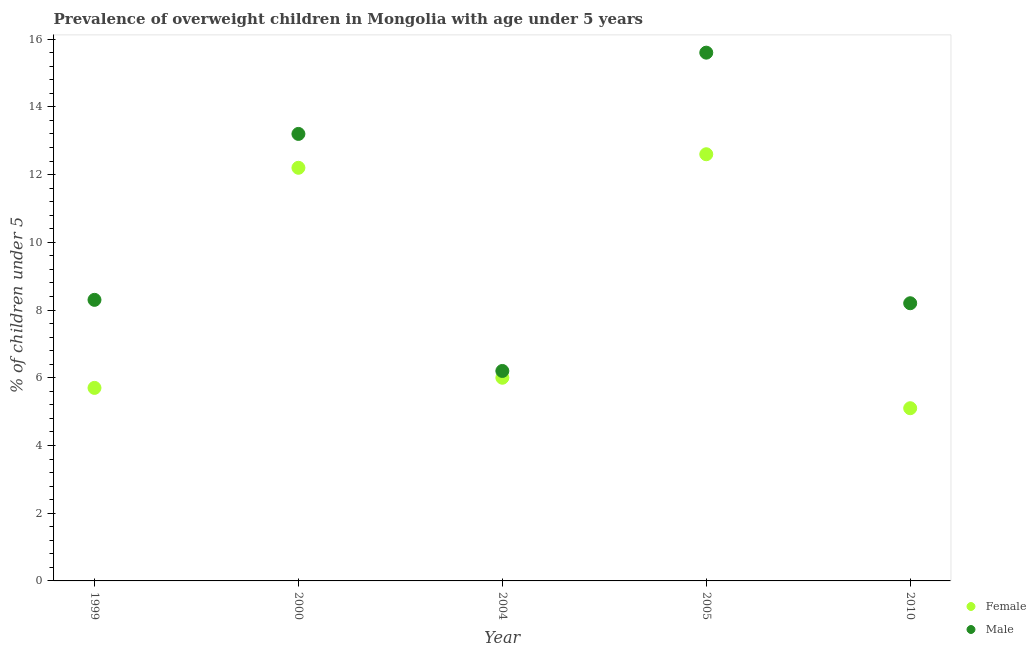Is the number of dotlines equal to the number of legend labels?
Offer a very short reply. Yes. What is the percentage of obese female children in 2000?
Provide a short and direct response. 12.2. Across all years, what is the maximum percentage of obese female children?
Your answer should be very brief. 12.6. Across all years, what is the minimum percentage of obese male children?
Offer a very short reply. 6.2. In which year was the percentage of obese female children maximum?
Make the answer very short. 2005. What is the total percentage of obese female children in the graph?
Give a very brief answer. 41.6. What is the difference between the percentage of obese female children in 2000 and that in 2005?
Make the answer very short. -0.4. What is the difference between the percentage of obese male children in 1999 and the percentage of obese female children in 2004?
Your answer should be compact. 2.3. What is the average percentage of obese male children per year?
Keep it short and to the point. 10.3. In how many years, is the percentage of obese female children greater than 2.8 %?
Keep it short and to the point. 5. What is the ratio of the percentage of obese female children in 2004 to that in 2005?
Offer a terse response. 0.48. What is the difference between the highest and the second highest percentage of obese female children?
Your answer should be very brief. 0.4. What is the difference between the highest and the lowest percentage of obese female children?
Offer a very short reply. 7.5. Is the sum of the percentage of obese male children in 1999 and 2010 greater than the maximum percentage of obese female children across all years?
Keep it short and to the point. Yes. How many years are there in the graph?
Make the answer very short. 5. What is the difference between two consecutive major ticks on the Y-axis?
Provide a succinct answer. 2. Are the values on the major ticks of Y-axis written in scientific E-notation?
Ensure brevity in your answer.  No. Where does the legend appear in the graph?
Make the answer very short. Bottom right. How many legend labels are there?
Your answer should be compact. 2. What is the title of the graph?
Keep it short and to the point. Prevalence of overweight children in Mongolia with age under 5 years. What is the label or title of the X-axis?
Make the answer very short. Year. What is the label or title of the Y-axis?
Your answer should be compact.  % of children under 5. What is the  % of children under 5 of Female in 1999?
Make the answer very short. 5.7. What is the  % of children under 5 of Male in 1999?
Make the answer very short. 8.3. What is the  % of children under 5 of Female in 2000?
Keep it short and to the point. 12.2. What is the  % of children under 5 of Male in 2000?
Ensure brevity in your answer.  13.2. What is the  % of children under 5 in Female in 2004?
Keep it short and to the point. 6. What is the  % of children under 5 of Male in 2004?
Offer a terse response. 6.2. What is the  % of children under 5 in Female in 2005?
Provide a succinct answer. 12.6. What is the  % of children under 5 in Male in 2005?
Keep it short and to the point. 15.6. What is the  % of children under 5 of Female in 2010?
Give a very brief answer. 5.1. What is the  % of children under 5 in Male in 2010?
Keep it short and to the point. 8.2. Across all years, what is the maximum  % of children under 5 in Female?
Provide a short and direct response. 12.6. Across all years, what is the maximum  % of children under 5 of Male?
Make the answer very short. 15.6. Across all years, what is the minimum  % of children under 5 in Female?
Keep it short and to the point. 5.1. Across all years, what is the minimum  % of children under 5 of Male?
Give a very brief answer. 6.2. What is the total  % of children under 5 of Female in the graph?
Ensure brevity in your answer.  41.6. What is the total  % of children under 5 of Male in the graph?
Your answer should be very brief. 51.5. What is the difference between the  % of children under 5 of Female in 1999 and that in 2000?
Your answer should be very brief. -6.5. What is the difference between the  % of children under 5 of Male in 1999 and that in 2000?
Provide a short and direct response. -4.9. What is the difference between the  % of children under 5 of Female in 1999 and that in 2004?
Provide a succinct answer. -0.3. What is the difference between the  % of children under 5 in Female in 1999 and that in 2005?
Your response must be concise. -6.9. What is the difference between the  % of children under 5 in Female in 1999 and that in 2010?
Make the answer very short. 0.6. What is the difference between the  % of children under 5 in Male in 1999 and that in 2010?
Your answer should be compact. 0.1. What is the difference between the  % of children under 5 in Female in 2000 and that in 2005?
Your answer should be very brief. -0.4. What is the difference between the  % of children under 5 in Male in 2000 and that in 2005?
Ensure brevity in your answer.  -2.4. What is the difference between the  % of children under 5 of Male in 2000 and that in 2010?
Ensure brevity in your answer.  5. What is the difference between the  % of children under 5 in Female in 2004 and that in 2010?
Ensure brevity in your answer.  0.9. What is the difference between the  % of children under 5 of Male in 2004 and that in 2010?
Offer a terse response. -2. What is the difference between the  % of children under 5 in Female in 2005 and that in 2010?
Keep it short and to the point. 7.5. What is the difference between the  % of children under 5 in Female in 1999 and the  % of children under 5 in Male in 2000?
Offer a terse response. -7.5. What is the difference between the  % of children under 5 of Female in 1999 and the  % of children under 5 of Male in 2005?
Offer a very short reply. -9.9. What is the difference between the  % of children under 5 in Female in 2000 and the  % of children under 5 in Male in 2010?
Your response must be concise. 4. What is the difference between the  % of children under 5 of Female in 2004 and the  % of children under 5 of Male in 2005?
Provide a short and direct response. -9.6. What is the difference between the  % of children under 5 of Female in 2005 and the  % of children under 5 of Male in 2010?
Your response must be concise. 4.4. What is the average  % of children under 5 in Female per year?
Offer a very short reply. 8.32. What is the average  % of children under 5 of Male per year?
Make the answer very short. 10.3. In the year 1999, what is the difference between the  % of children under 5 of Female and  % of children under 5 of Male?
Make the answer very short. -2.6. In the year 2000, what is the difference between the  % of children under 5 of Female and  % of children under 5 of Male?
Keep it short and to the point. -1. What is the ratio of the  % of children under 5 in Female in 1999 to that in 2000?
Make the answer very short. 0.47. What is the ratio of the  % of children under 5 in Male in 1999 to that in 2000?
Your answer should be very brief. 0.63. What is the ratio of the  % of children under 5 in Female in 1999 to that in 2004?
Make the answer very short. 0.95. What is the ratio of the  % of children under 5 of Male in 1999 to that in 2004?
Ensure brevity in your answer.  1.34. What is the ratio of the  % of children under 5 of Female in 1999 to that in 2005?
Your answer should be very brief. 0.45. What is the ratio of the  % of children under 5 in Male in 1999 to that in 2005?
Offer a terse response. 0.53. What is the ratio of the  % of children under 5 of Female in 1999 to that in 2010?
Provide a short and direct response. 1.12. What is the ratio of the  % of children under 5 of Male in 1999 to that in 2010?
Ensure brevity in your answer.  1.01. What is the ratio of the  % of children under 5 of Female in 2000 to that in 2004?
Provide a short and direct response. 2.03. What is the ratio of the  % of children under 5 of Male in 2000 to that in 2004?
Ensure brevity in your answer.  2.13. What is the ratio of the  % of children under 5 in Female in 2000 to that in 2005?
Make the answer very short. 0.97. What is the ratio of the  % of children under 5 of Male in 2000 to that in 2005?
Your response must be concise. 0.85. What is the ratio of the  % of children under 5 in Female in 2000 to that in 2010?
Your answer should be compact. 2.39. What is the ratio of the  % of children under 5 in Male in 2000 to that in 2010?
Make the answer very short. 1.61. What is the ratio of the  % of children under 5 in Female in 2004 to that in 2005?
Provide a succinct answer. 0.48. What is the ratio of the  % of children under 5 in Male in 2004 to that in 2005?
Your response must be concise. 0.4. What is the ratio of the  % of children under 5 of Female in 2004 to that in 2010?
Offer a very short reply. 1.18. What is the ratio of the  % of children under 5 in Male in 2004 to that in 2010?
Provide a short and direct response. 0.76. What is the ratio of the  % of children under 5 of Female in 2005 to that in 2010?
Keep it short and to the point. 2.47. What is the ratio of the  % of children under 5 of Male in 2005 to that in 2010?
Give a very brief answer. 1.9. What is the difference between the highest and the second highest  % of children under 5 in Female?
Your answer should be compact. 0.4. What is the difference between the highest and the second highest  % of children under 5 of Male?
Offer a terse response. 2.4. What is the difference between the highest and the lowest  % of children under 5 in Male?
Your answer should be compact. 9.4. 